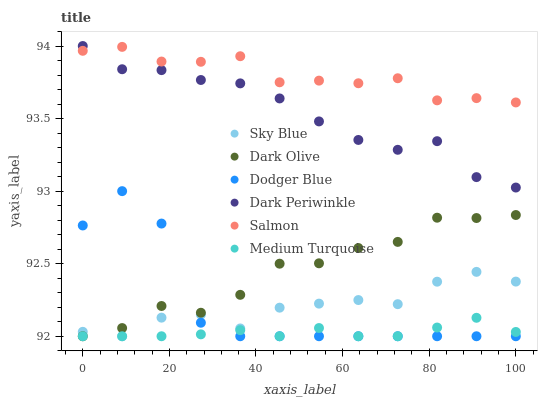Does Medium Turquoise have the minimum area under the curve?
Answer yes or no. Yes. Does Salmon have the maximum area under the curve?
Answer yes or no. Yes. Does Dodger Blue have the minimum area under the curve?
Answer yes or no. No. Does Dodger Blue have the maximum area under the curve?
Answer yes or no. No. Is Medium Turquoise the smoothest?
Answer yes or no. Yes. Is Dodger Blue the roughest?
Answer yes or no. Yes. Is Salmon the smoothest?
Answer yes or no. No. Is Salmon the roughest?
Answer yes or no. No. Does Dark Olive have the lowest value?
Answer yes or no. Yes. Does Salmon have the lowest value?
Answer yes or no. No. Does Dark Periwinkle have the highest value?
Answer yes or no. Yes. Does Salmon have the highest value?
Answer yes or no. No. Is Medium Turquoise less than Salmon?
Answer yes or no. Yes. Is Dark Periwinkle greater than Dodger Blue?
Answer yes or no. Yes. Does Dark Olive intersect Medium Turquoise?
Answer yes or no. Yes. Is Dark Olive less than Medium Turquoise?
Answer yes or no. No. Is Dark Olive greater than Medium Turquoise?
Answer yes or no. No. Does Medium Turquoise intersect Salmon?
Answer yes or no. No. 